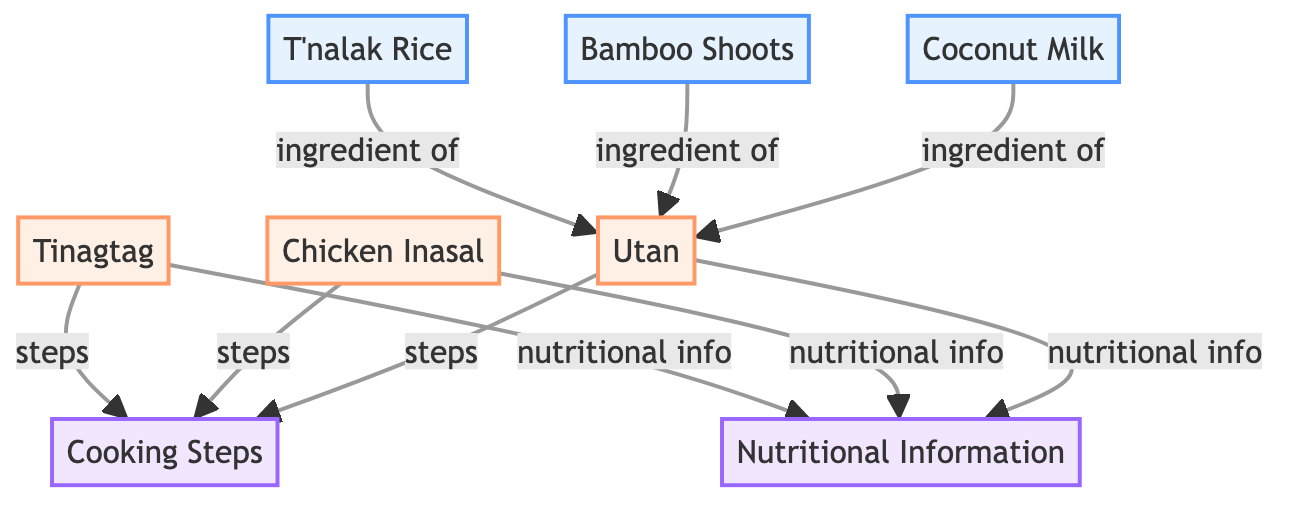What is one ingredient of Utan? From the diagram, we can see that T'nalak Rice, Bamboo Shoots, and Coconut Milk are listed as ingredients for Utan. Thus, one ingredient of Utan is Bamboo Shoots.
Answer: Bamboo Shoots How many dishes are shown in the diagram? The diagram presents three dishes: Tinagtag, Chicken Inasal, and Utan. Therefore, the total number of dishes is three.
Answer: 3 What are the cooking steps associated with Chicken Inasal? The diagram indicates that Chicken Inasal has specific cooking steps listed under the "Cooking Steps" category. However, the exact steps are not provided in the diagram; it only identifies that there are steps related to Chicken Inasal.
Answer: Steps (not specified) Which dish has nutritional information listed? Both Tinagtag and Chicken Inasal have nutritional information listed in the diagram, indicating that they both include health-related details associated with their preparation or ingredients.
Answer: Tinagtag, Chicken Inasal What type of diagram is this? The diagram is a Textbook Diagram, which typically organizes information visually to present educational content clearly. It helps illustrate relationships between various elements, such as ingredients and dishes in this case.
Answer: Textbook Diagram What is the nutritional information category listed? The diagram clearly categorizes "Nutritional Information" as one of the primary sections, indicating where nutritional details related to the dishes can be found.
Answer: Nutritional Information Which ingredient is common between Utan and Chicken Inasal? Looking at the ingredients for both dishes, it is indicated that Coconut Milk is used in both Utan and Chicken Inasal, showing a shared ingredient across the two dishes.
Answer: Coconut Milk Which dish is visually represented first in the diagram? The diagram lists Tinagtag first under the "dish" category, making it the first dish visually represented in the flow of information.
Answer: Tinagtag 